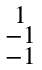Convert formula to latex. <formula><loc_0><loc_0><loc_500><loc_500>\begin{smallmatrix} 1 \\ - 1 \\ - 1 \end{smallmatrix}</formula> 